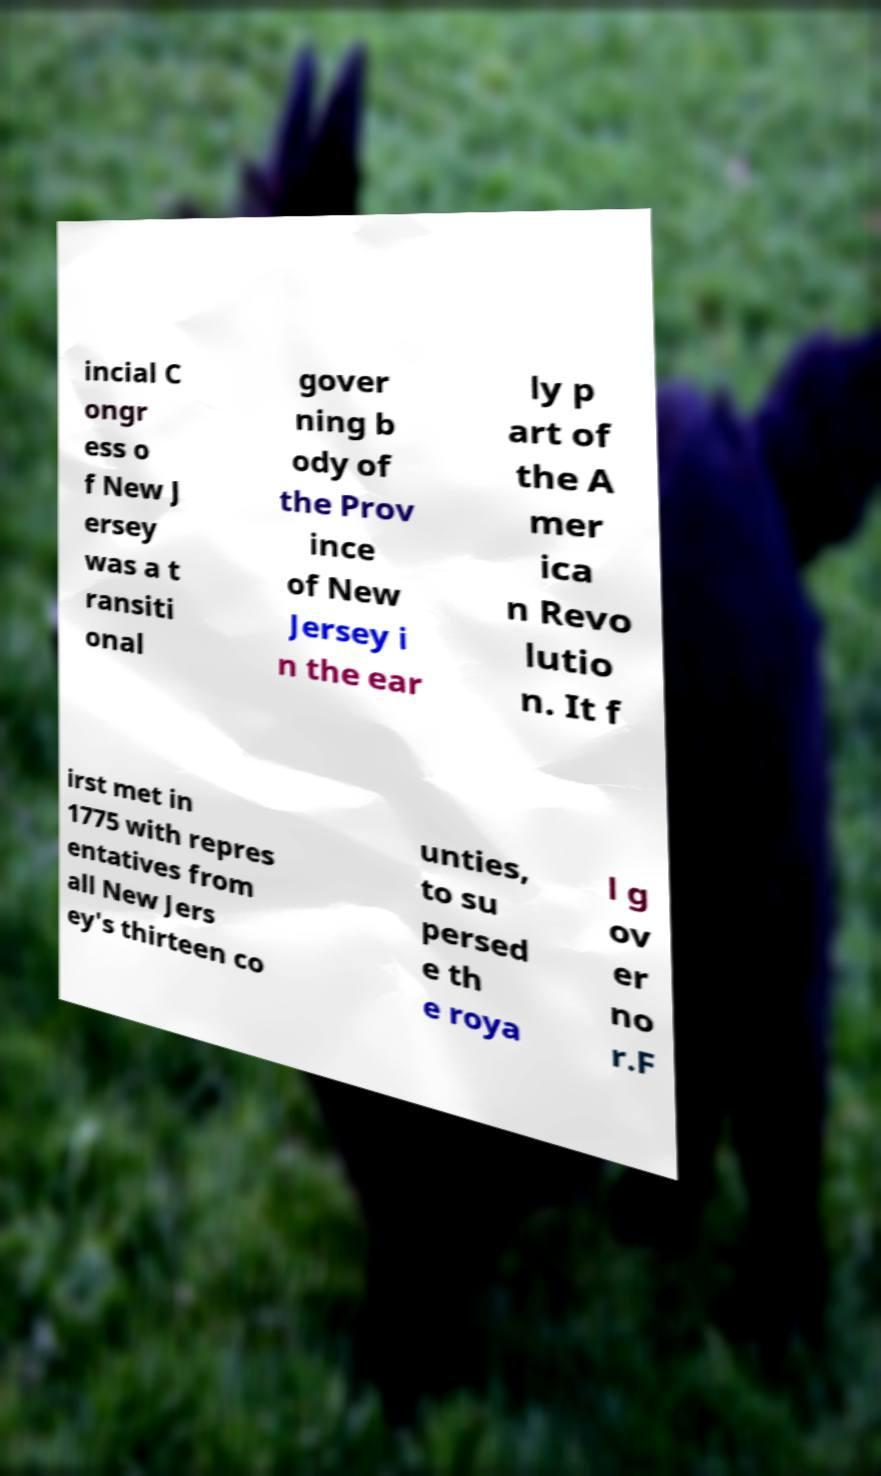Please read and relay the text visible in this image. What does it say? incial C ongr ess o f New J ersey was a t ransiti onal gover ning b ody of the Prov ince of New Jersey i n the ear ly p art of the A mer ica n Revo lutio n. It f irst met in 1775 with repres entatives from all New Jers ey's thirteen co unties, to su persed e th e roya l g ov er no r.F 